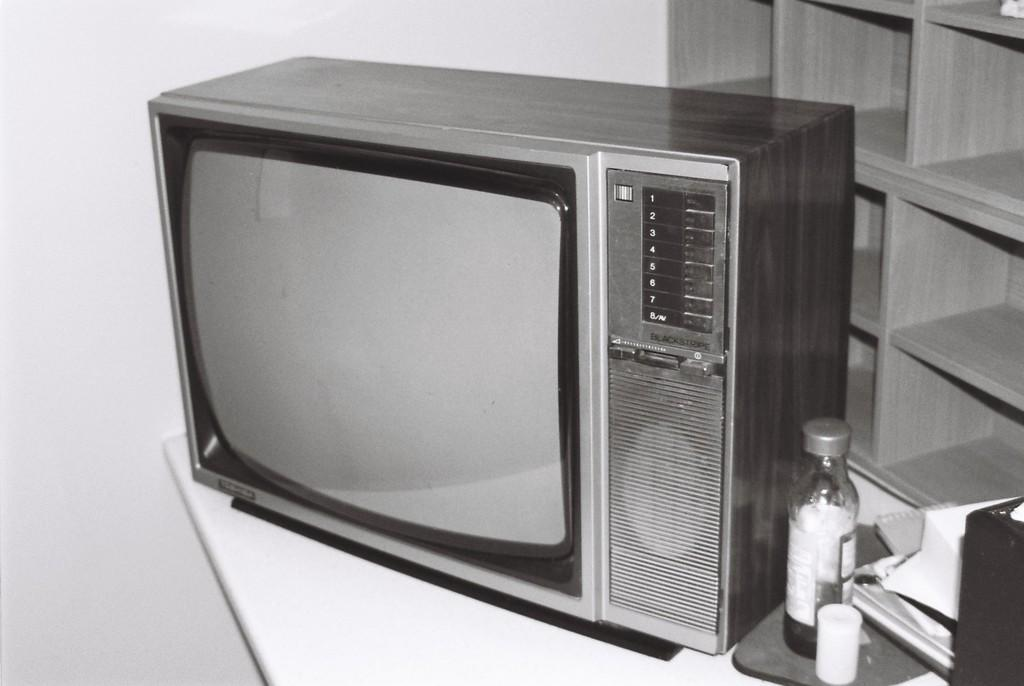What type of furniture is present in the image? There is a table in the image. What is located above the table? A television is above the table. What type of object can be seen in the image that might contain a liquid? There is a bottle in the image. What type of items can be seen in the image that might be used for reading or learning? There are books in the image. What can be seen in the background of the image? There is a wall and a cupboard in the background of the image. How many minutes does the stream take to flow across the image? There is no stream present in the image, so it is not possible to determine how many minutes it would take for a stream to flow across the image. 